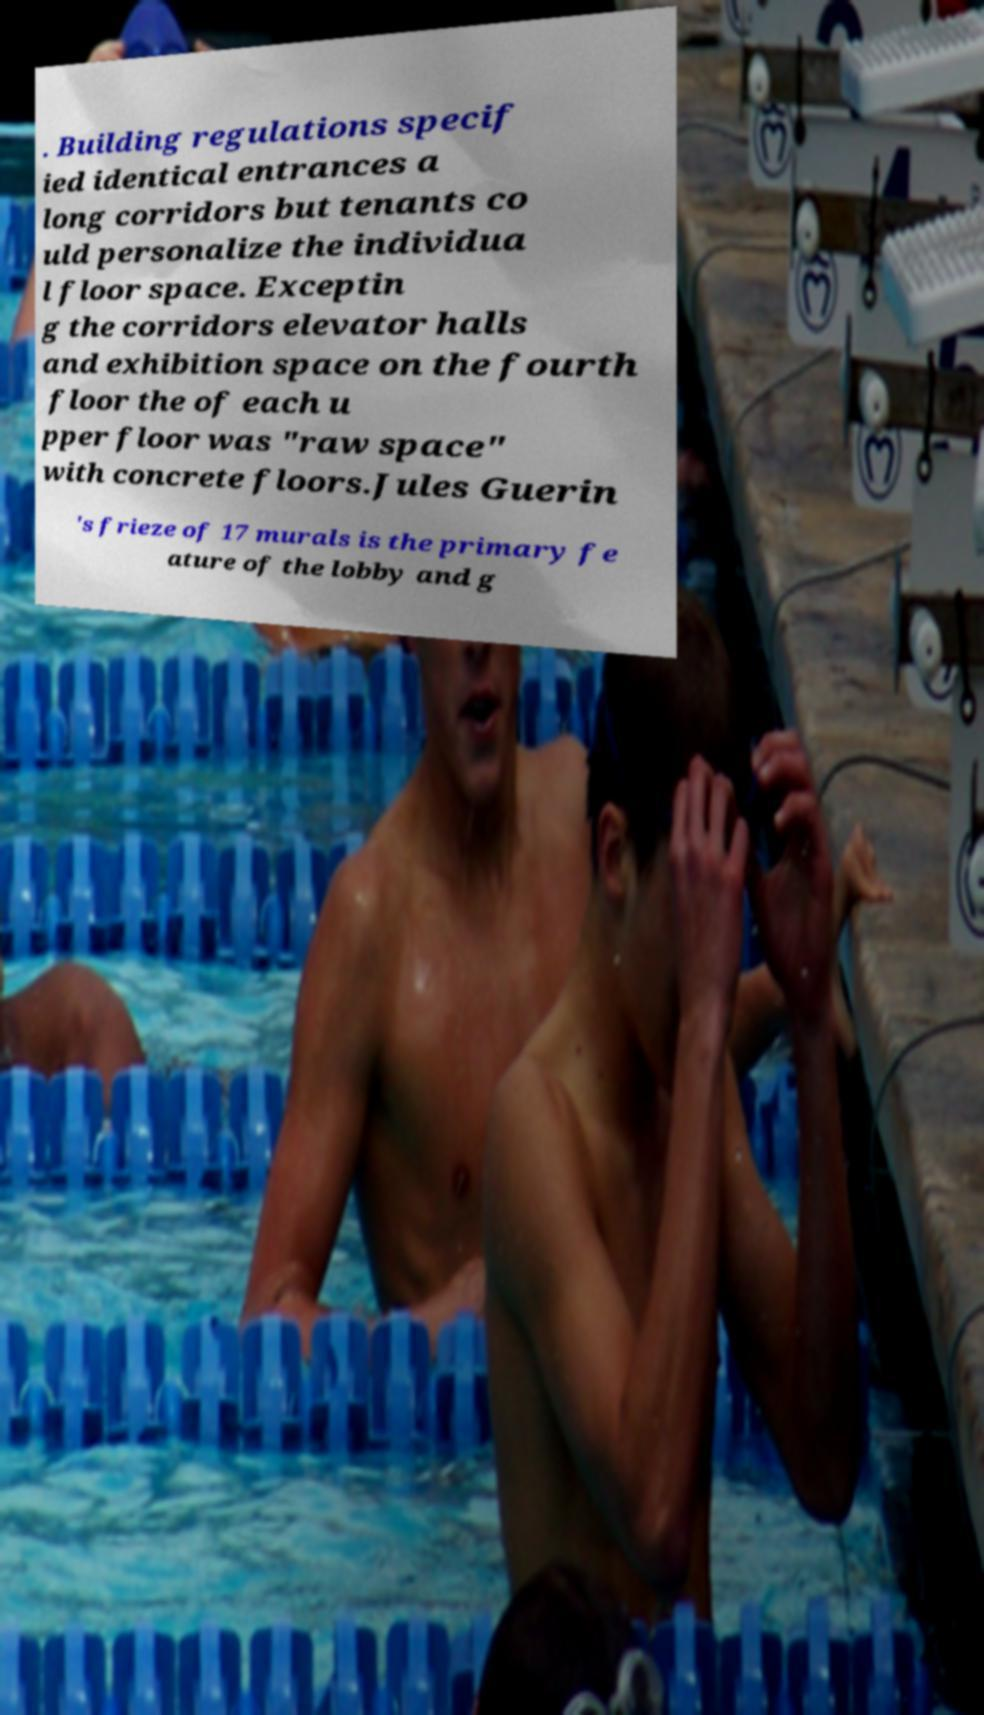Can you read and provide the text displayed in the image?This photo seems to have some interesting text. Can you extract and type it out for me? . Building regulations specif ied identical entrances a long corridors but tenants co uld personalize the individua l floor space. Exceptin g the corridors elevator halls and exhibition space on the fourth floor the of each u pper floor was "raw space" with concrete floors.Jules Guerin 's frieze of 17 murals is the primary fe ature of the lobby and g 